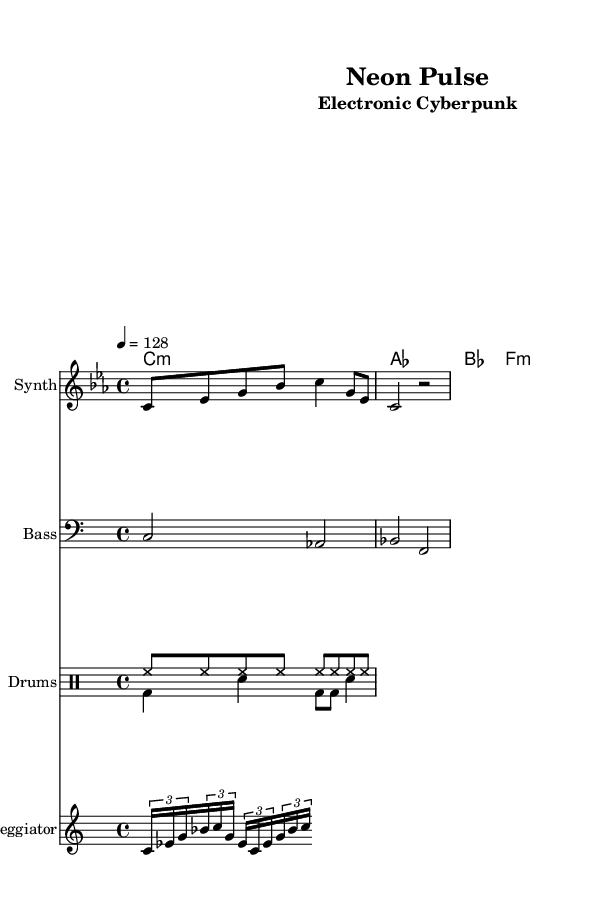What is the key signature of this music? The key signature is C minor, indicated by the presence of three flats (B flat, E flat, and A flat) in the music.
Answer: C minor What is the time signature of this music? The time signature is 4/4, which means there are four beats per measure and a quarter note receives one beat. This is shown in the first measure of the sheet music.
Answer: 4/4 What is the tempo marking of this piece? The tempo marking indicates a speed of 128 beats per minute, shown at the beginning of the score.
Answer: 128 How many measures does the melody section have? The melody section consists of two measures, as indicated by the two bar lines separating them in the sheet music.
Answer: 2 What type of chords are used in this piece? The chords of this piece include minor and major chords, which is typical for electronic music, and they are labeled accordingly in the chord names section.
Answer: Minor and Major Which instrument is designated for the main melody? The main melody is designated for the Synth, as indicated by the instrument name above the corresponding staff.
Answer: Synth What rhythmic pattern is used in the drum section? The drum section features a combination of hi-hat and bass drum patterns which contribute to the driving rhythm of the electronic style. The patterns are labeled as hi-hat and bass drum in the drum section.
Answer: Hi-hat and Bass drum 